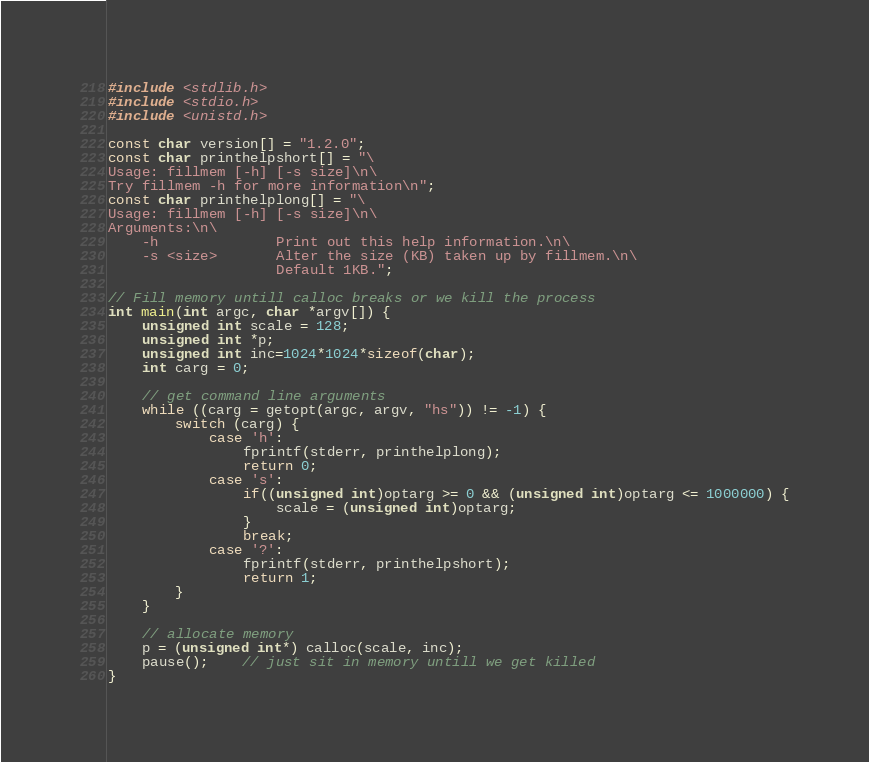<code> <loc_0><loc_0><loc_500><loc_500><_C_>#include <stdlib.h>
#include <stdio.h>
#include <unistd.h>

const char version[] = "1.2.0";
const char printhelpshort[] = "\
Usage: fillmem [-h] [-s size]\n\
Try fillmem -h for more information\n";
const char printhelplong[] = "\
Usage: fillmem [-h] [-s size]\n\
Arguments:\n\
    -h              Print out this help information.\n\
    -s <size>       Alter the size (KB) taken up by fillmem.\n\
                    Default 1KB.";

// Fill memory untill calloc breaks or we kill the process
int main(int argc, char *argv[]) {
    unsigned int scale = 128;
    unsigned int *p;
    unsigned int inc=1024*1024*sizeof(char);
    int carg = 0;

    // get command line arguments
    while ((carg = getopt(argc, argv, "hs")) != -1) {
        switch (carg) {
            case 'h':
                fprintf(stderr, printhelplong);
                return 0;
            case 's':
                if((unsigned int)optarg >= 0 && (unsigned int)optarg <= 1000000) {
                    scale = (unsigned int)optarg;
                }
                break;
            case '?':
                fprintf(stderr, printhelpshort);
                return 1;
        }
    }
    
    // allocate memory
    p = (unsigned int*) calloc(scale, inc);
    pause();    // just sit in memory untill we get killed
}
</code> 